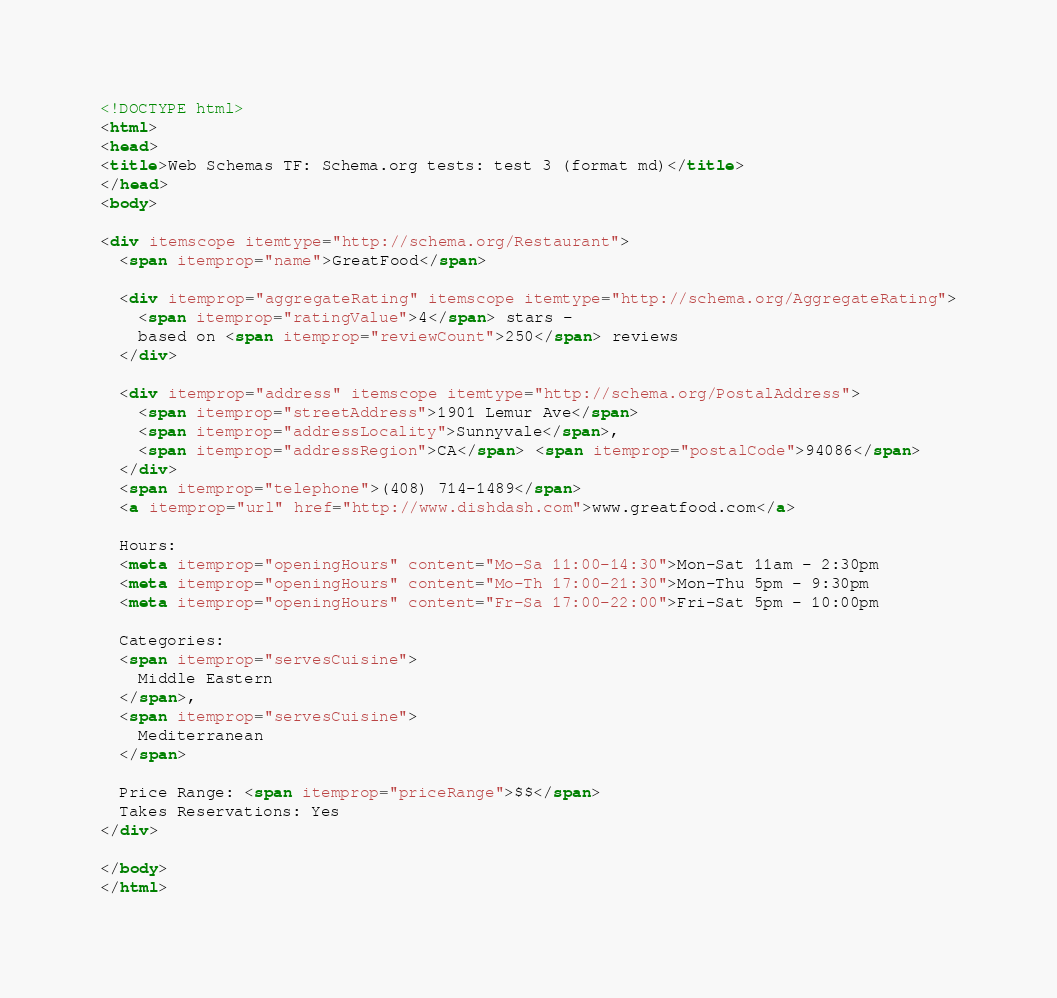<code> <loc_0><loc_0><loc_500><loc_500><_HTML_><!DOCTYPE html>
<html>
<head>
<title>Web Schemas TF: Schema.org tests: test 3 (format md)</title>
</head>
<body>

<div itemscope itemtype="http://schema.org/Restaurant">
  <span itemprop="name">GreatFood</span>

  <div itemprop="aggregateRating" itemscope itemtype="http://schema.org/AggregateRating">
    <span itemprop="ratingValue">4</span> stars -
    based on <span itemprop="reviewCount">250</span> reviews
  </div>

  <div itemprop="address" itemscope itemtype="http://schema.org/PostalAddress">
    <span itemprop="streetAddress">1901 Lemur Ave</span>
    <span itemprop="addressLocality">Sunnyvale</span>,
    <span itemprop="addressRegion">CA</span> <span itemprop="postalCode">94086</span>
  </div>
  <span itemprop="telephone">(408) 714-1489</span>
  <a itemprop="url" href="http://www.dishdash.com">www.greatfood.com</a>

  Hours:
  <meta itemprop="openingHours" content="Mo-Sa 11:00-14:30">Mon-Sat 11am - 2:30pm
  <meta itemprop="openingHours" content="Mo-Th 17:00-21:30">Mon-Thu 5pm - 9:30pm
  <meta itemprop="openingHours" content="Fr-Sa 17:00-22:00">Fri-Sat 5pm - 10:00pm

  Categories:
  <span itemprop="servesCuisine">
    Middle Eastern
  </span>,
  <span itemprop="servesCuisine">
    Mediterranean
  </span>

  Price Range: <span itemprop="priceRange">$$</span>
  Takes Reservations: Yes
</div>

</body>
</html>
</code> 